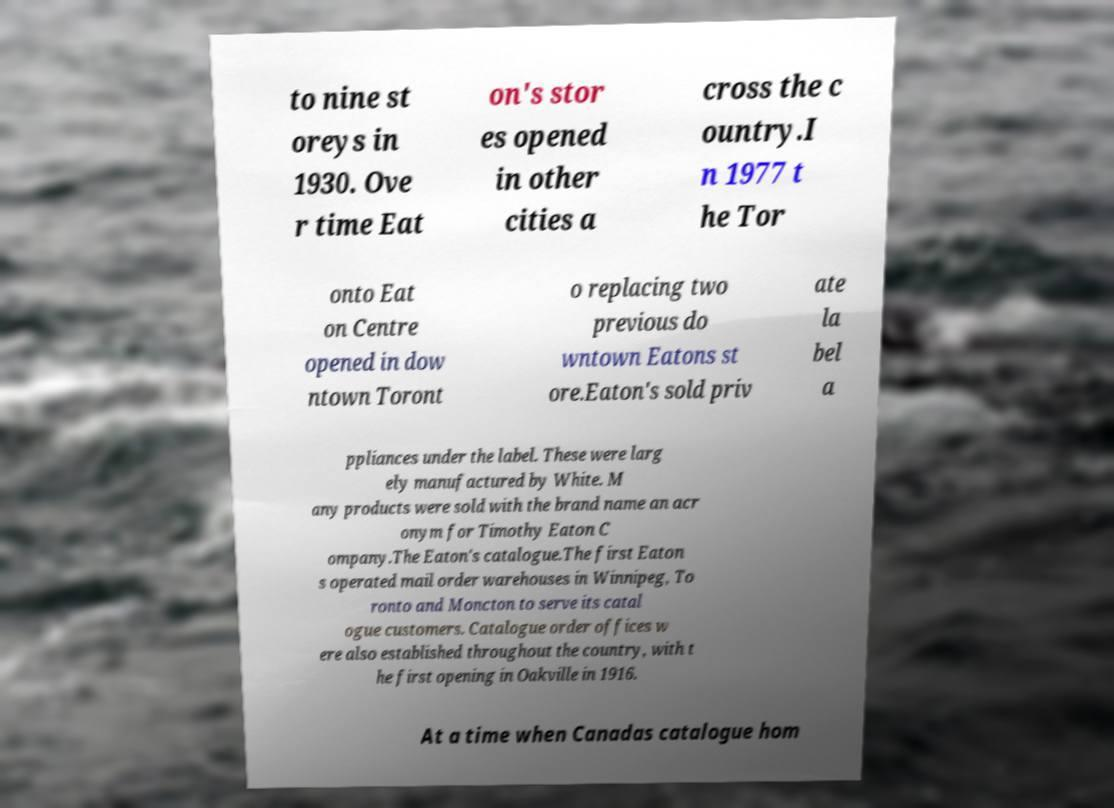Please identify and transcribe the text found in this image. to nine st oreys in 1930. Ove r time Eat on's stor es opened in other cities a cross the c ountry.I n 1977 t he Tor onto Eat on Centre opened in dow ntown Toront o replacing two previous do wntown Eatons st ore.Eaton's sold priv ate la bel a ppliances under the label. These were larg ely manufactured by White. M any products were sold with the brand name an acr onym for Timothy Eaton C ompany.The Eaton's catalogue.The first Eaton s operated mail order warehouses in Winnipeg, To ronto and Moncton to serve its catal ogue customers. Catalogue order offices w ere also established throughout the country, with t he first opening in Oakville in 1916. At a time when Canadas catalogue hom 